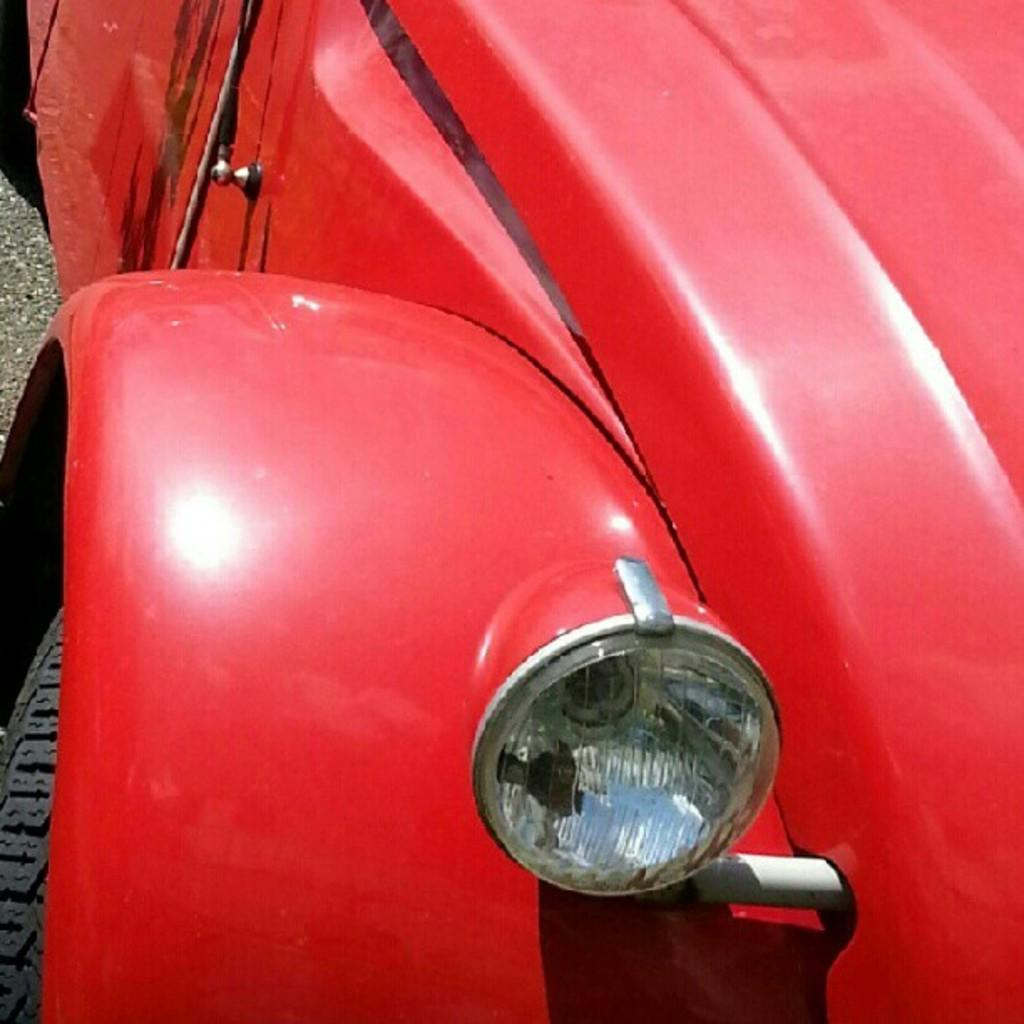What color is the car in the image? The car in the image is red. What is the position of the bonnet on the car? The bonnet is on the right side of the car. What is one of the features of the car's front? The car has a headlight. What is located on the left side of the car? The car has a tire on the left side. Where is the car situated in the image? The car is on the road. Can you see any alley cats playing near the car in the image? There is no mention of alley cats or any animals in the image; it only features a red car on the road. 